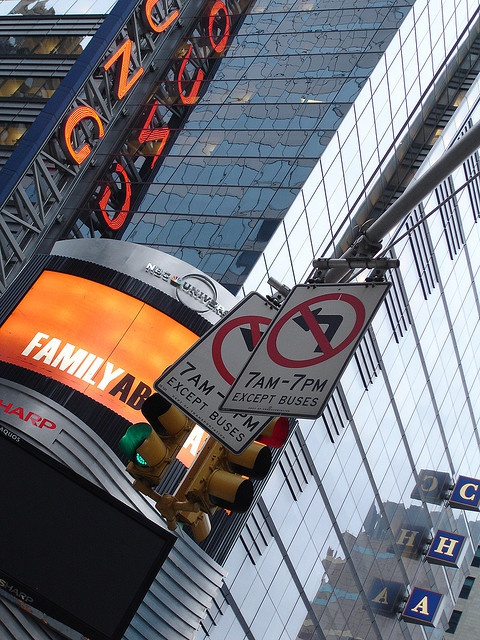Describe the objects in this image and their specific colors. I can see a traffic light in gray, black, maroon, and olive tones in this image. 